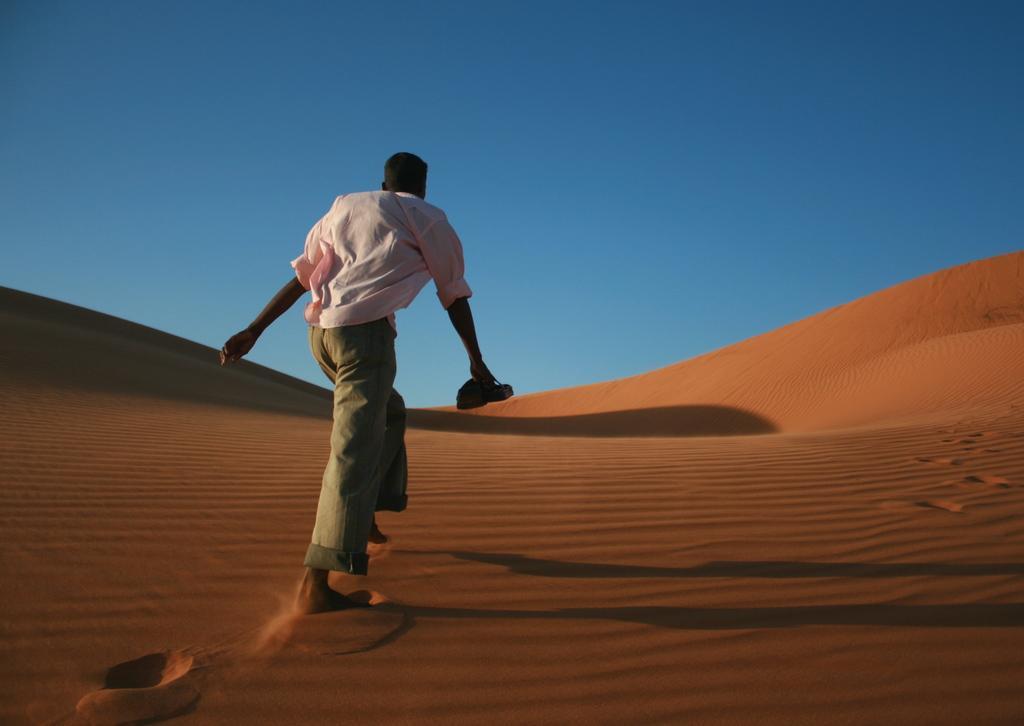Could you give a brief overview of what you see in this image? In this image I can see a person standing in the desert. In the background I can see the sky. 